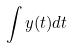<formula> <loc_0><loc_0><loc_500><loc_500>\int y ( t ) d t</formula> 